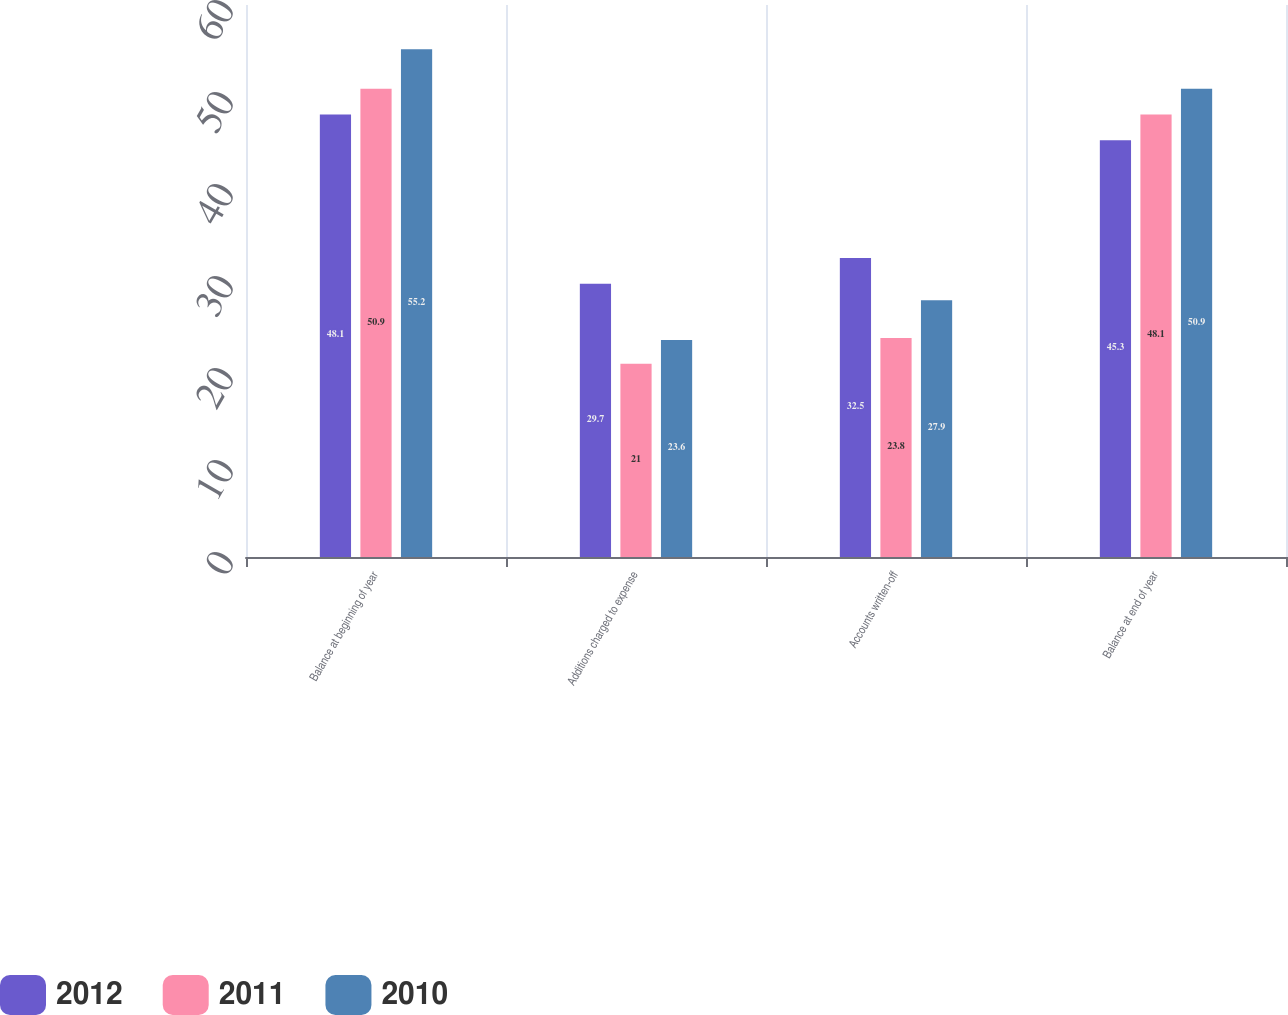Convert chart to OTSL. <chart><loc_0><loc_0><loc_500><loc_500><stacked_bar_chart><ecel><fcel>Balance at beginning of year<fcel>Additions charged to expense<fcel>Accounts written-off<fcel>Balance at end of year<nl><fcel>2012<fcel>48.1<fcel>29.7<fcel>32.5<fcel>45.3<nl><fcel>2011<fcel>50.9<fcel>21<fcel>23.8<fcel>48.1<nl><fcel>2010<fcel>55.2<fcel>23.6<fcel>27.9<fcel>50.9<nl></chart> 